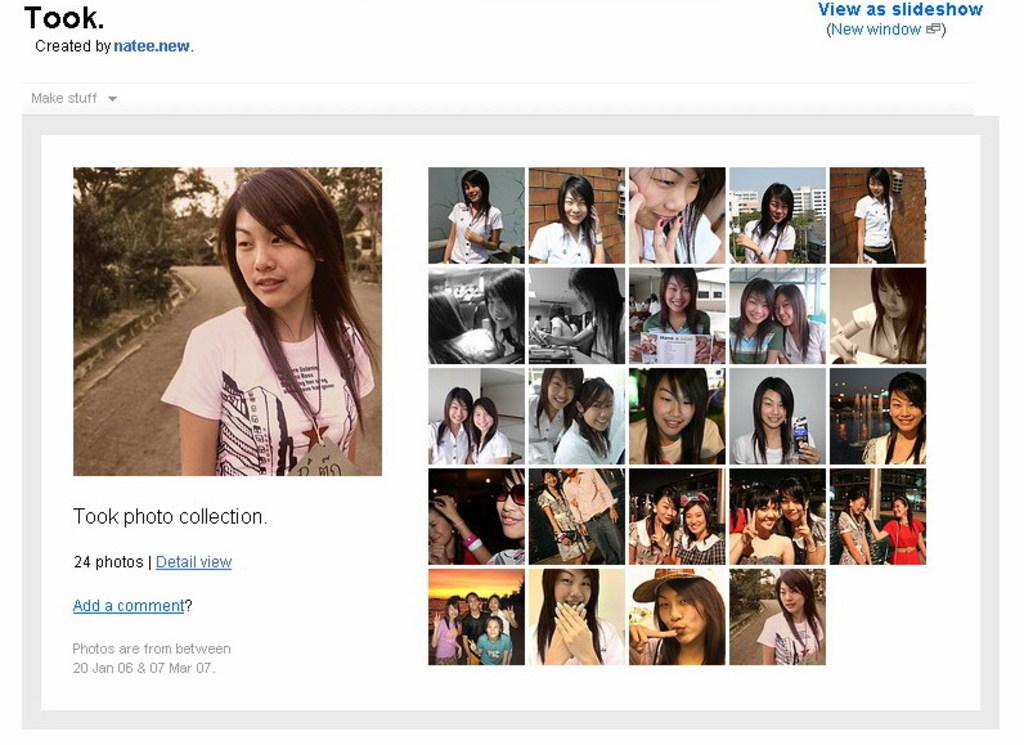What type of image is being described? The image is a screenshot in a system. What can be seen in the screenshot? There are pictures of a person in the image. Are there any other elements in the screenshot besides the pictures of the person? Yes, there is text present in the image. Can you tell me how many times the person in the image is reading a book? There is no indication in the image that the person is reading a book, so it cannot be determined from the picture. 